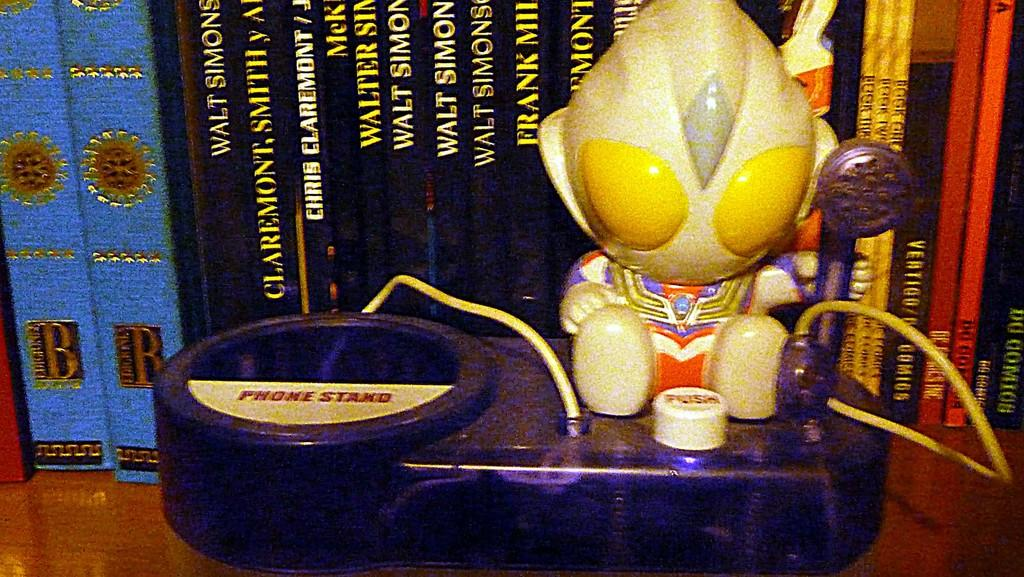What object can be seen in the foreground of the image? There is a toy in the image. What can be seen in the background of the image? There are books in the background of the image. How are the books arranged in the image? The books appear to be on a rack. What type of wren can be seen perched on the toy in the image? There is no wren present in the image; it only features a toy and books on a rack. 